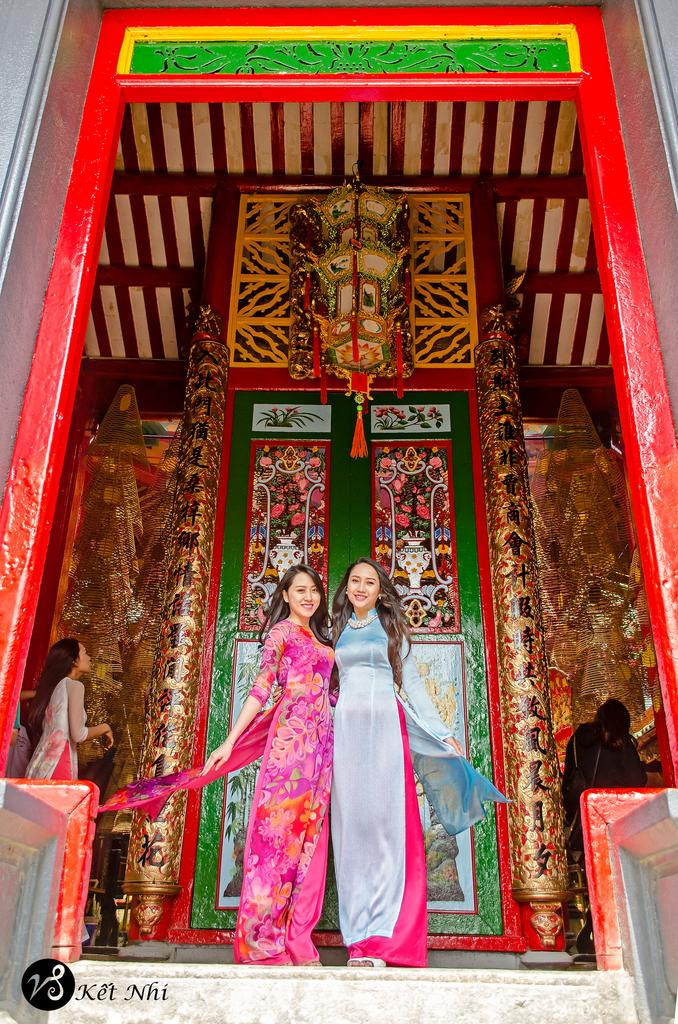What is the main subject of the image? The main subject of the image is the women standing in the center. Where are the women standing? The women are standing on the floor. What can be seen in the background of the image? There is a door and a building in the background of the image. What type of appliance is causing the women to feel angry in the image? There is no appliance or indication of anger in the image; it simply shows women standing on the floor with a door and a building in the background. 